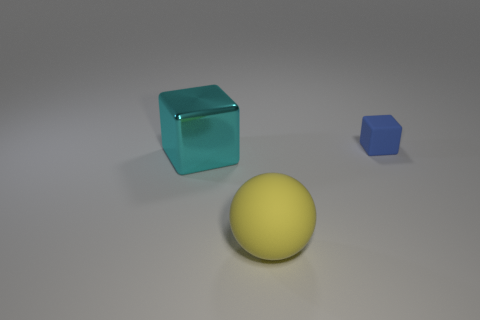Is there anything else that has the same material as the cyan thing?
Provide a short and direct response. No. Are there more blue objects that are on the left side of the big cyan shiny cube than rubber things that are behind the big yellow matte object?
Your response must be concise. No. Does the ball have the same material as the block that is on the left side of the large yellow sphere?
Your answer should be very brief. No. There is a block to the right of the large object in front of the large cyan thing; how many cyan things are to the right of it?
Keep it short and to the point. 0. Do the small blue object and the rubber object that is in front of the blue rubber object have the same shape?
Offer a terse response. No. There is a thing that is behind the sphere and on the right side of the large cyan cube; what is its color?
Offer a terse response. Blue. There is a thing that is in front of the large object that is left of the rubber object in front of the tiny blue block; what is it made of?
Provide a succinct answer. Rubber. What is the material of the cyan block?
Keep it short and to the point. Metal. There is another blue thing that is the same shape as the big shiny thing; what is its size?
Your response must be concise. Small. Is the color of the big metal object the same as the big matte ball?
Your response must be concise. No. 